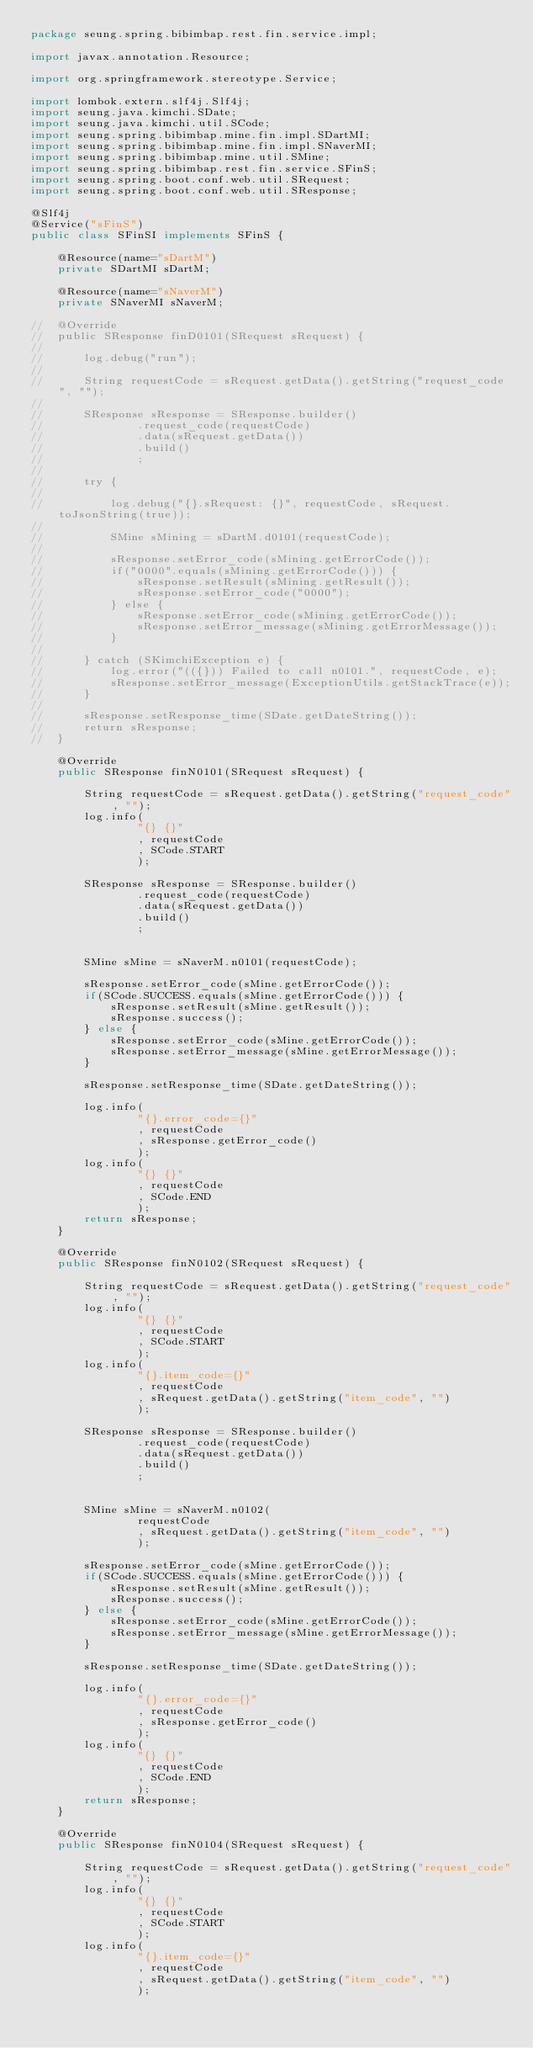Convert code to text. <code><loc_0><loc_0><loc_500><loc_500><_Java_>package seung.spring.bibimbap.rest.fin.service.impl;

import javax.annotation.Resource;

import org.springframework.stereotype.Service;

import lombok.extern.slf4j.Slf4j;
import seung.java.kimchi.SDate;
import seung.java.kimchi.util.SCode;
import seung.spring.bibimbap.mine.fin.impl.SDartMI;
import seung.spring.bibimbap.mine.fin.impl.SNaverMI;
import seung.spring.bibimbap.mine.util.SMine;
import seung.spring.bibimbap.rest.fin.service.SFinS;
import seung.spring.boot.conf.web.util.SRequest;
import seung.spring.boot.conf.web.util.SResponse;

@Slf4j
@Service("sFinS")
public class SFinSI implements SFinS {

	@Resource(name="sDartM")
	private SDartMI sDartM;
	
	@Resource(name="sNaverM")
	private SNaverMI sNaverM;
	
//	@Override
//	public SResponse finD0101(SRequest sRequest) {
//		
//		log.debug("run");
//		
//		String requestCode = sRequest.getData().getString("request_code", "");
//		
//		SResponse sResponse = SResponse.builder()
//				.request_code(requestCode)
//				.data(sRequest.getData())
//				.build()
//				;
//		
//		try {
//			
//			log.debug("{}.sRequest: {}", requestCode, sRequest.toJsonString(true));
//			
//			SMine sMining = sDartM.d0101(requestCode);
//			
//			sResponse.setError_code(sMining.getErrorCode());
//			if("0000".equals(sMining.getErrorCode())) {
//				sResponse.setResult(sMining.getResult());
//				sResponse.setError_code("0000");
//			} else {
//				sResponse.setError_code(sMining.getErrorCode());
//				sResponse.setError_message(sMining.getErrorMessage());
//			}
//			
//		} catch (SKimchiException e) {
//			log.error("(({})) Failed to call n0101.", requestCode, e);
//			sResponse.setError_message(ExceptionUtils.getStackTrace(e));
//		}
//		
//		sResponse.setResponse_time(SDate.getDateString());
//		return sResponse;
//	}
	
	@Override
	public SResponse finN0101(SRequest sRequest) {
		
		String requestCode = sRequest.getData().getString("request_code", "");
		log.info(
				"{} {}"
				, requestCode
				, SCode.START
				);
		
		SResponse sResponse = SResponse.builder()
				.request_code(requestCode)
				.data(sRequest.getData())
				.build()
				;
		
		
		SMine sMine = sNaverM.n0101(requestCode);
		
		sResponse.setError_code(sMine.getErrorCode());
		if(SCode.SUCCESS.equals(sMine.getErrorCode())) {
			sResponse.setResult(sMine.getResult());
			sResponse.success();
		} else {
			sResponse.setError_code(sMine.getErrorCode());
			sResponse.setError_message(sMine.getErrorMessage());
		}
		
		sResponse.setResponse_time(SDate.getDateString());
		
		log.info(
				"{}.error_code={}"
				, requestCode
				, sResponse.getError_code()
				);
		log.info(
				"{} {}"
				, requestCode
				, SCode.END
				);
		return sResponse;
	}
	
	@Override
	public SResponse finN0102(SRequest sRequest) {
		
		String requestCode = sRequest.getData().getString("request_code", "");
		log.info(
				"{} {}"
				, requestCode
				, SCode.START
				);
		log.info(
				"{}.item_code={}"
				, requestCode
				, sRequest.getData().getString("item_code", "")
				);
		
		SResponse sResponse = SResponse.builder()
				.request_code(requestCode)
				.data(sRequest.getData())
				.build()
				;
		
		
		SMine sMine = sNaverM.n0102(
				requestCode
				, sRequest.getData().getString("item_code", "")
				);
		
		sResponse.setError_code(sMine.getErrorCode());
		if(SCode.SUCCESS.equals(sMine.getErrorCode())) {
			sResponse.setResult(sMine.getResult());
			sResponse.success();
		} else {
			sResponse.setError_code(sMine.getErrorCode());
			sResponse.setError_message(sMine.getErrorMessage());
		}
		
		sResponse.setResponse_time(SDate.getDateString());
		
		log.info(
				"{}.error_code={}"
				, requestCode
				, sResponse.getError_code()
				);
		log.info(
				"{} {}"
				, requestCode
				, SCode.END
				);
		return sResponse;
	}
	
	@Override
	public SResponse finN0104(SRequest sRequest) {
		
		String requestCode = sRequest.getData().getString("request_code", "");
		log.info(
				"{} {}"
				, requestCode
				, SCode.START
				);
		log.info(
				"{}.item_code={}"
				, requestCode
				, sRequest.getData().getString("item_code", "")
				);
		</code> 